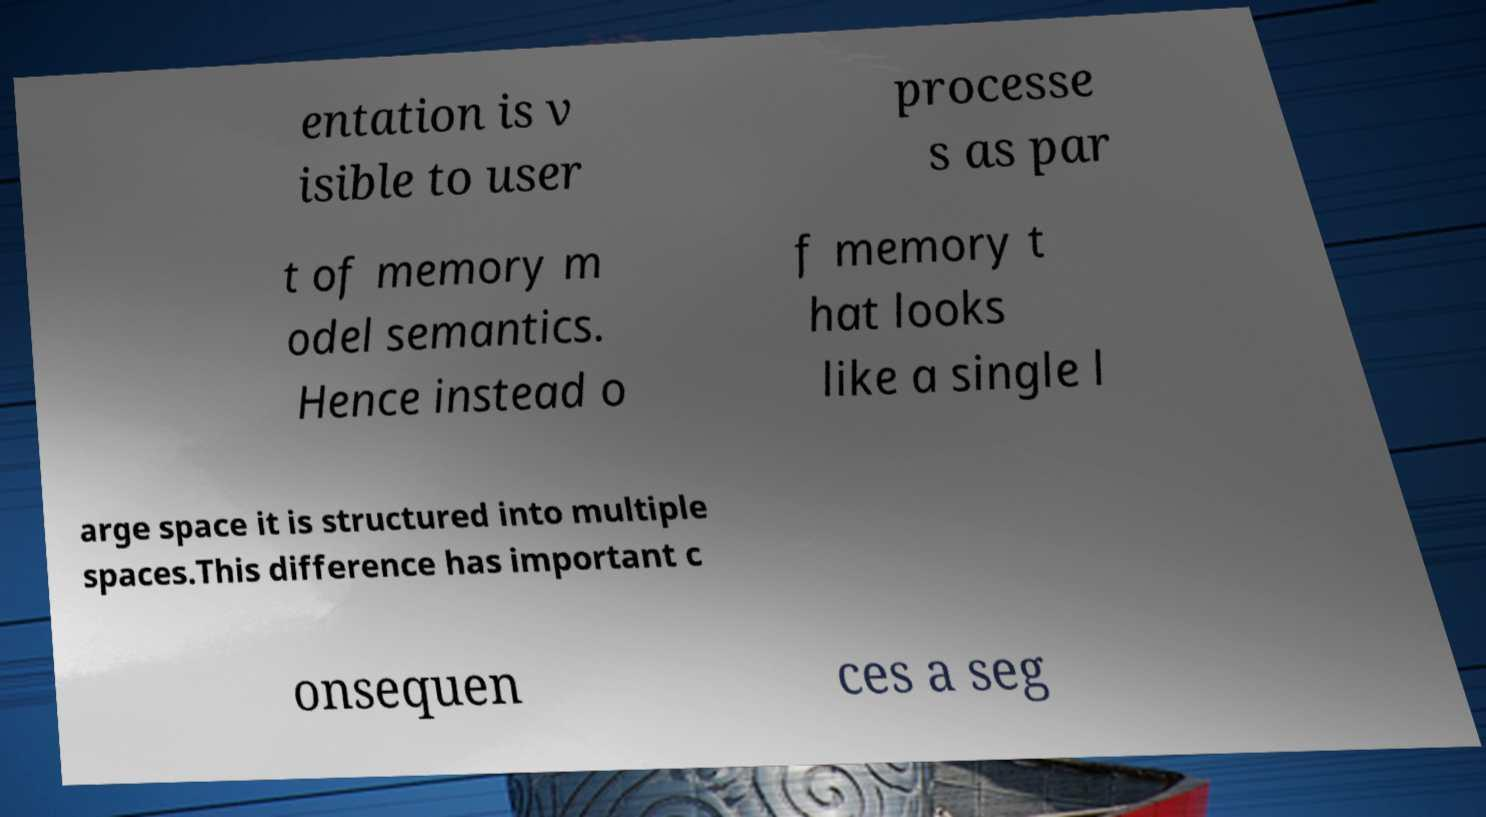For documentation purposes, I need the text within this image transcribed. Could you provide that? entation is v isible to user processe s as par t of memory m odel semantics. Hence instead o f memory t hat looks like a single l arge space it is structured into multiple spaces.This difference has important c onsequen ces a seg 